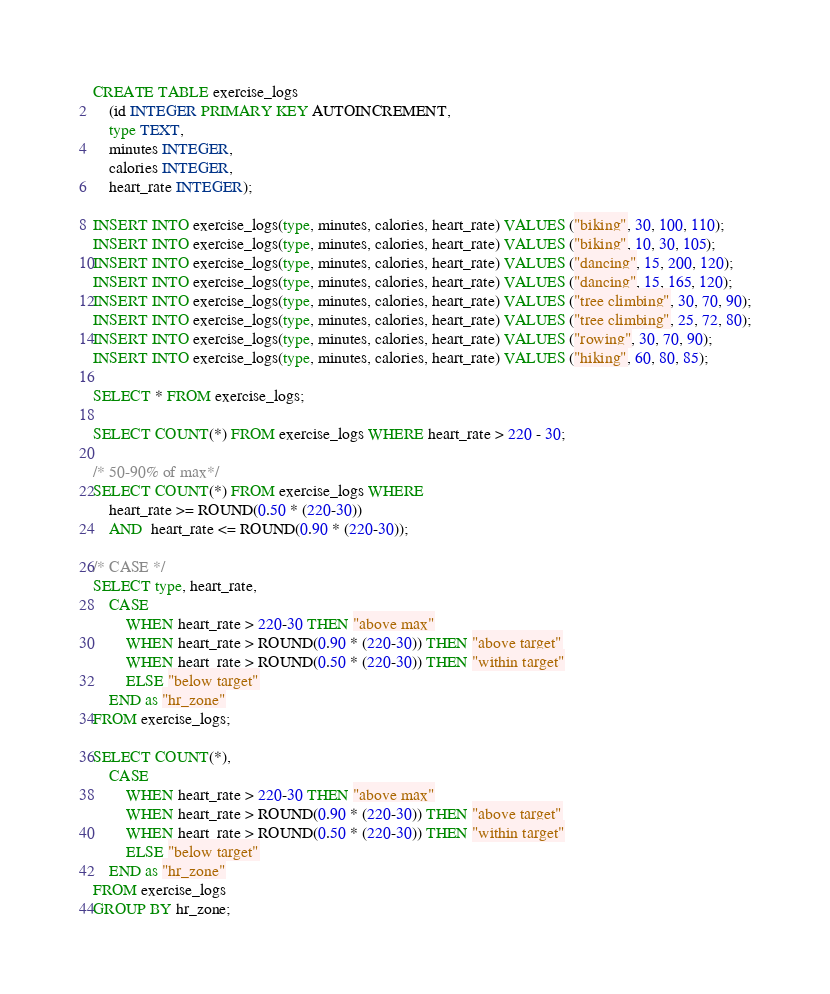<code> <loc_0><loc_0><loc_500><loc_500><_SQL_>CREATE TABLE exercise_logs
    (id INTEGER PRIMARY KEY AUTOINCREMENT,
    type TEXT,
    minutes INTEGER, 
    calories INTEGER,
    heart_rate INTEGER);

INSERT INTO exercise_logs(type, minutes, calories, heart_rate) VALUES ("biking", 30, 100, 110);
INSERT INTO exercise_logs(type, minutes, calories, heart_rate) VALUES ("biking", 10, 30, 105);
INSERT INTO exercise_logs(type, minutes, calories, heart_rate) VALUES ("dancing", 15, 200, 120);
INSERT INTO exercise_logs(type, minutes, calories, heart_rate) VALUES ("dancing", 15, 165, 120);
INSERT INTO exercise_logs(type, minutes, calories, heart_rate) VALUES ("tree climbing", 30, 70, 90);
INSERT INTO exercise_logs(type, minutes, calories, heart_rate) VALUES ("tree climbing", 25, 72, 80);
INSERT INTO exercise_logs(type, minutes, calories, heart_rate) VALUES ("rowing", 30, 70, 90);
INSERT INTO exercise_logs(type, minutes, calories, heart_rate) VALUES ("hiking", 60, 80, 85);

SELECT * FROM exercise_logs;

SELECT COUNT(*) FROM exercise_logs WHERE heart_rate > 220 - 30;

/* 50-90% of max*/
SELECT COUNT(*) FROM exercise_logs WHERE
    heart_rate >= ROUND(0.50 * (220-30)) 
    AND  heart_rate <= ROUND(0.90 * (220-30));
    
/* CASE */
SELECT type, heart_rate,
    CASE 
        WHEN heart_rate > 220-30 THEN "above max"
        WHEN heart_rate > ROUND(0.90 * (220-30)) THEN "above target"
        WHEN heart_rate > ROUND(0.50 * (220-30)) THEN "within target"
        ELSE "below target"
    END as "hr_zone"
FROM exercise_logs;

SELECT COUNT(*),
    CASE 
        WHEN heart_rate > 220-30 THEN "above max"
        WHEN heart_rate > ROUND(0.90 * (220-30)) THEN "above target"
        WHEN heart_rate > ROUND(0.50 * (220-30)) THEN "within target"
        ELSE "below target"
    END as "hr_zone"
FROM exercise_logs
GROUP BY hr_zone;</code> 